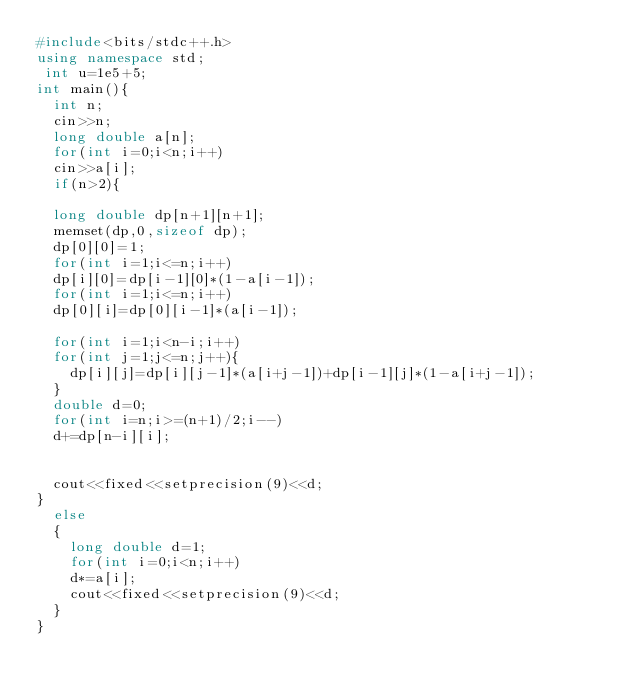<code> <loc_0><loc_0><loc_500><loc_500><_C++_>#include<bits/stdc++.h>
using namespace std;
 int u=1e5+5;
int main(){
	int n;
	cin>>n;
	long double a[n];
	for(int i=0;i<n;i++)
	cin>>a[i];
	if(n>2){
		
	long double dp[n+1][n+1];
	memset(dp,0,sizeof dp);
	dp[0][0]=1;
	for(int i=1;i<=n;i++)
	dp[i][0]=dp[i-1][0]*(1-a[i-1]);
	for(int i=1;i<=n;i++)
	dp[0][i]=dp[0][i-1]*(a[i-1]);
	
	for(int i=1;i<n-i;i++)
	for(int j=1;j<=n;j++){
		dp[i][j]=dp[i][j-1]*(a[i+j-1])+dp[i-1][j]*(1-a[i+j-1]);
	}
	double d=0;
	for(int i=n;i>=(n+1)/2;i--)
	d+=dp[n-i][i];
	
	
	cout<<fixed<<setprecision(9)<<d;
}
	else
	{
		long double d=1;
		for(int i=0;i<n;i++)
		d*=a[i];
		cout<<fixed<<setprecision(9)<<d;
	}
}</code> 